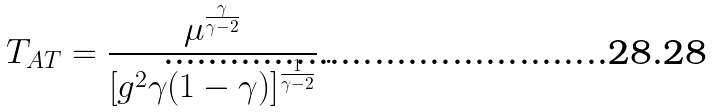Convert formula to latex. <formula><loc_0><loc_0><loc_500><loc_500>T _ { A T } = \frac { \mu ^ { \frac { \gamma } { \gamma - 2 } } } { \left [ g ^ { 2 } \gamma ( 1 - \gamma ) \right ] ^ { \frac { 1 } { \gamma - 2 } } } \, .</formula> 